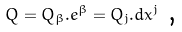Convert formula to latex. <formula><loc_0><loc_0><loc_500><loc_500>Q = Q _ { \beta } . e ^ { \beta } = Q _ { j } . d x ^ { j } \text { ,}</formula> 